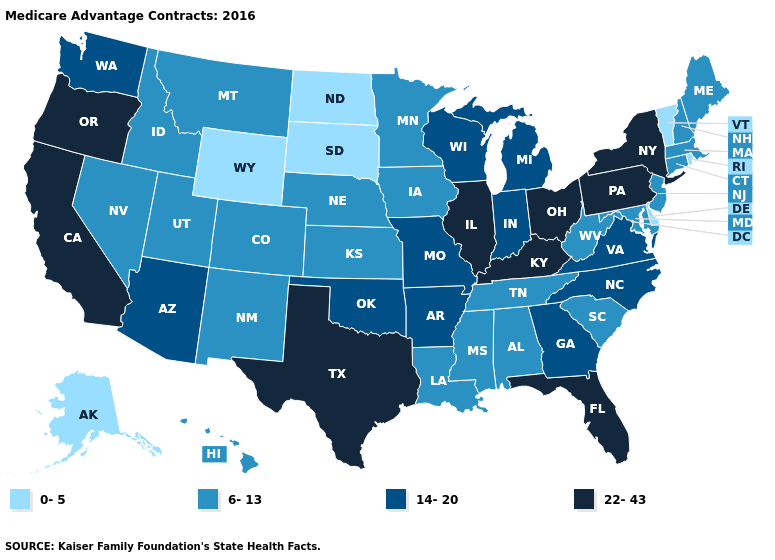Name the states that have a value in the range 14-20?
Write a very short answer. Arkansas, Arizona, Georgia, Indiana, Michigan, Missouri, North Carolina, Oklahoma, Virginia, Washington, Wisconsin. Does the first symbol in the legend represent the smallest category?
Answer briefly. Yes. Does Washington have a higher value than West Virginia?
Write a very short answer. Yes. What is the value of Iowa?
Keep it brief. 6-13. Is the legend a continuous bar?
Answer briefly. No. Among the states that border Illinois , which have the highest value?
Concise answer only. Kentucky. Among the states that border Louisiana , does Texas have the highest value?
Answer briefly. Yes. What is the value of Illinois?
Keep it brief. 22-43. What is the value of Missouri?
Answer briefly. 14-20. Name the states that have a value in the range 14-20?
Short answer required. Arkansas, Arizona, Georgia, Indiana, Michigan, Missouri, North Carolina, Oklahoma, Virginia, Washington, Wisconsin. What is the highest value in the West ?
Quick response, please. 22-43. What is the lowest value in states that border Utah?
Answer briefly. 0-5. Does Alabama have a lower value than West Virginia?
Concise answer only. No. Does Connecticut have a lower value than North Dakota?
Concise answer only. No. 